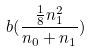<formula> <loc_0><loc_0><loc_500><loc_500>b ( \frac { \frac { 1 } { 8 } n _ { 1 } ^ { 2 } } { n _ { 0 } + n _ { 1 } } )</formula> 